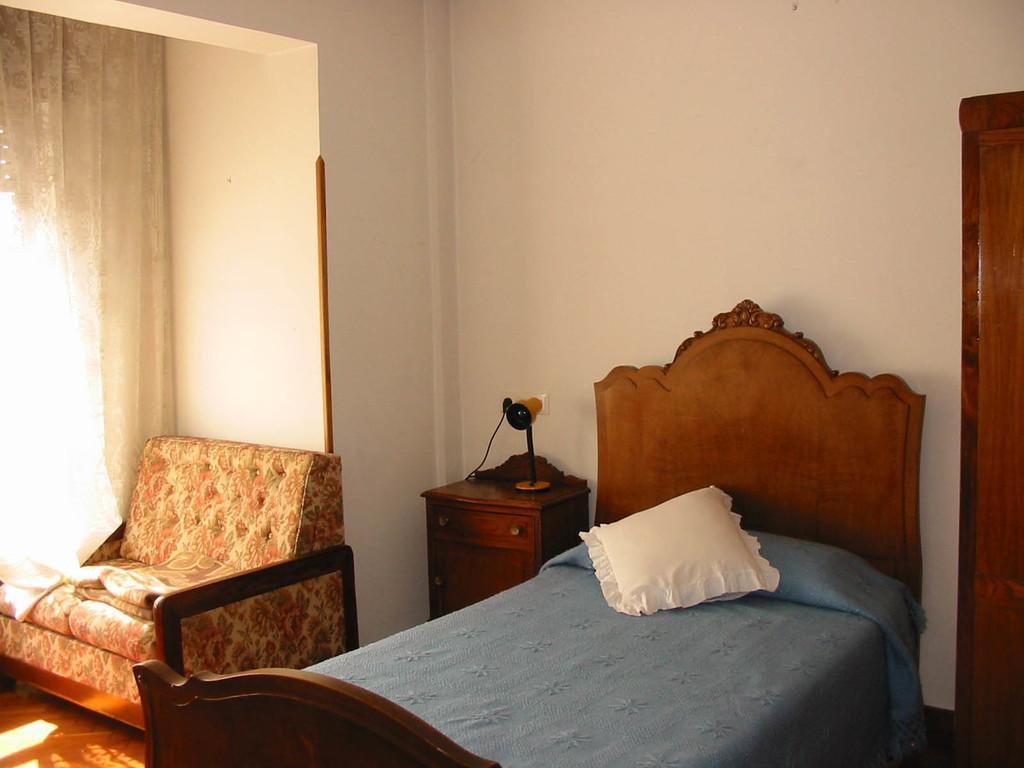How would you summarize this image in a sentence or two? Here we can see a cot and pillow on it, and at back here is the wall, and here is the sofa and here is the curtain. 